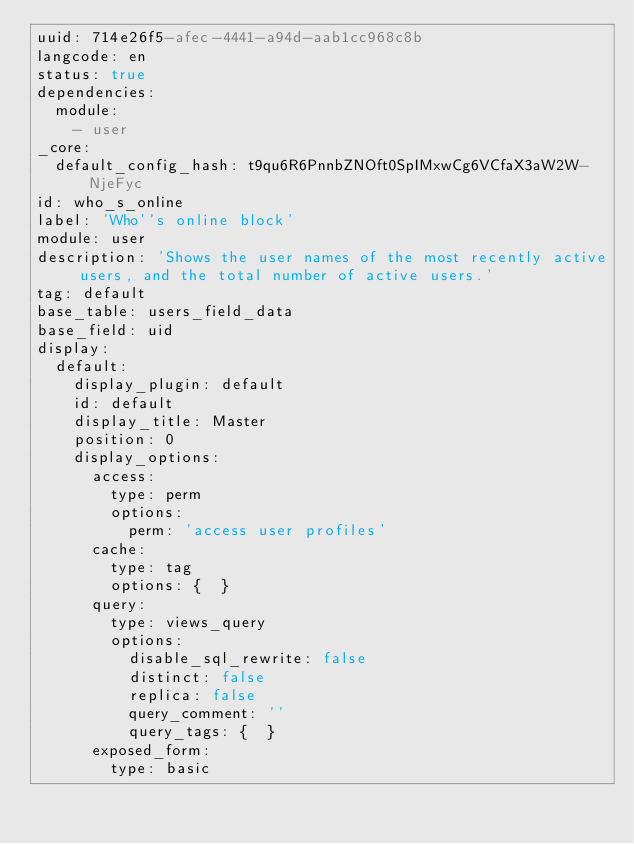Convert code to text. <code><loc_0><loc_0><loc_500><loc_500><_YAML_>uuid: 714e26f5-afec-4441-a94d-aab1cc968c8b
langcode: en
status: true
dependencies:
  module:
    - user
_core:
  default_config_hash: t9qu6R6PnnbZNOft0SpIMxwCg6VCfaX3aW2W-NjeFyc
id: who_s_online
label: 'Who''s online block'
module: user
description: 'Shows the user names of the most recently active users, and the total number of active users.'
tag: default
base_table: users_field_data
base_field: uid
display:
  default:
    display_plugin: default
    id: default
    display_title: Master
    position: 0
    display_options:
      access:
        type: perm
        options:
          perm: 'access user profiles'
      cache:
        type: tag
        options: {  }
      query:
        type: views_query
        options:
          disable_sql_rewrite: false
          distinct: false
          replica: false
          query_comment: ''
          query_tags: {  }
      exposed_form:
        type: basic</code> 